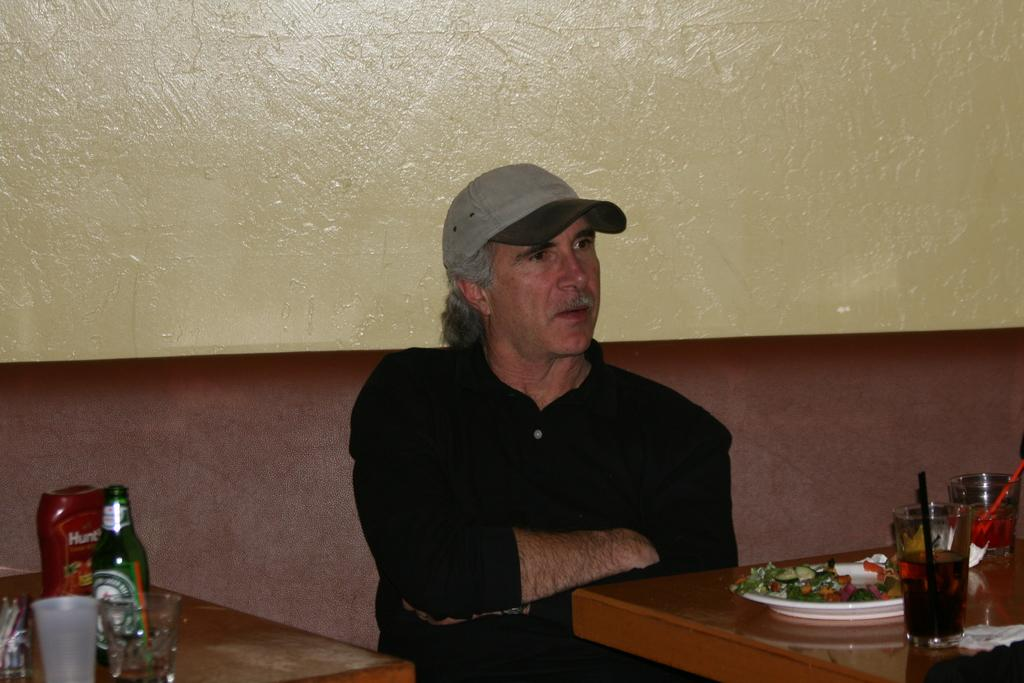<image>
Create a compact narrative representing the image presented. a Hunts ketchup bottle is next to a man in a hat 